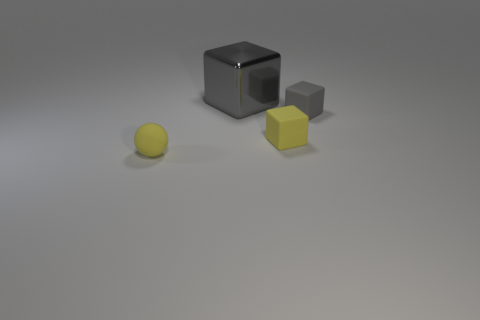Is there anything else that has the same material as the large gray thing?
Your response must be concise. No. Are there any big purple cylinders?
Your response must be concise. No. Is the number of yellow rubber objects on the right side of the large gray metal cube greater than the number of big gray metal cubes that are to the right of the yellow sphere?
Offer a terse response. No. There is a large cube that is behind the small yellow rubber sphere in front of the large thing; what is its color?
Your answer should be compact. Gray. Is there a small ball of the same color as the metallic thing?
Provide a short and direct response. No. There is a gray cube behind the small rubber object that is right of the yellow object behind the ball; how big is it?
Provide a short and direct response. Large. What shape is the small gray rubber thing?
Provide a short and direct response. Cube. How many tiny yellow matte blocks are behind the yellow matte object on the right side of the tiny rubber sphere?
Keep it short and to the point. 0. How many other objects are the same material as the large cube?
Your answer should be very brief. 0. Do the gray thing that is in front of the shiny block and the gray block to the left of the tiny gray rubber block have the same material?
Ensure brevity in your answer.  No. 